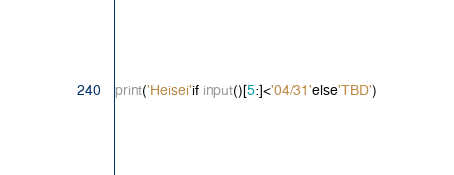Convert code to text. <code><loc_0><loc_0><loc_500><loc_500><_Python_>print('Heisei'if input()[5:]<'04/31'else'TBD')
</code> 